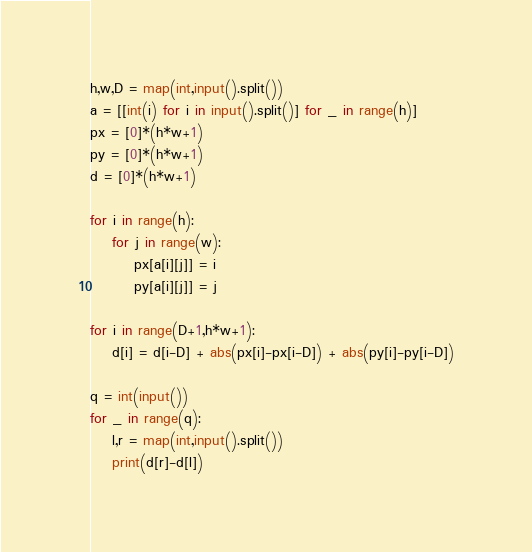Convert code to text. <code><loc_0><loc_0><loc_500><loc_500><_Python_>h,w,D = map(int,input().split())
a = [[int(i) for i in input().split()] for _ in range(h)]
px = [0]*(h*w+1)
py = [0]*(h*w+1)
d = [0]*(h*w+1)

for i in range(h):
    for j in range(w):
        px[a[i][j]] = i
        py[a[i][j]] = j

for i in range(D+1,h*w+1):
    d[i] = d[i-D] + abs(px[i]-px[i-D]) + abs(py[i]-py[i-D])

q = int(input())
for _ in range(q):
    l,r = map(int,input().split())
    print(d[r]-d[l])</code> 